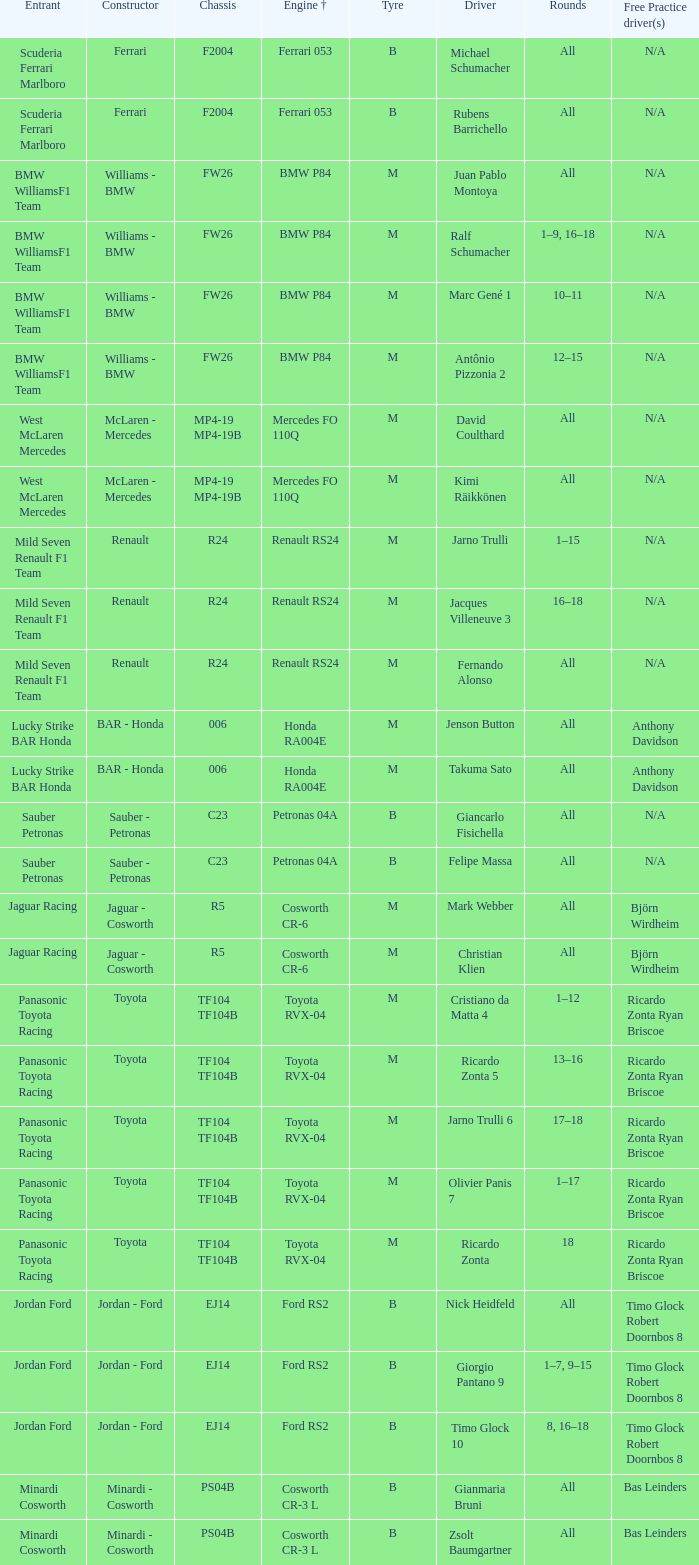What type of complimentary training is available for a ford rs2 engine +? Timo Glock Robert Doornbos 8, Timo Glock Robert Doornbos 8, Timo Glock Robert Doornbos 8. 